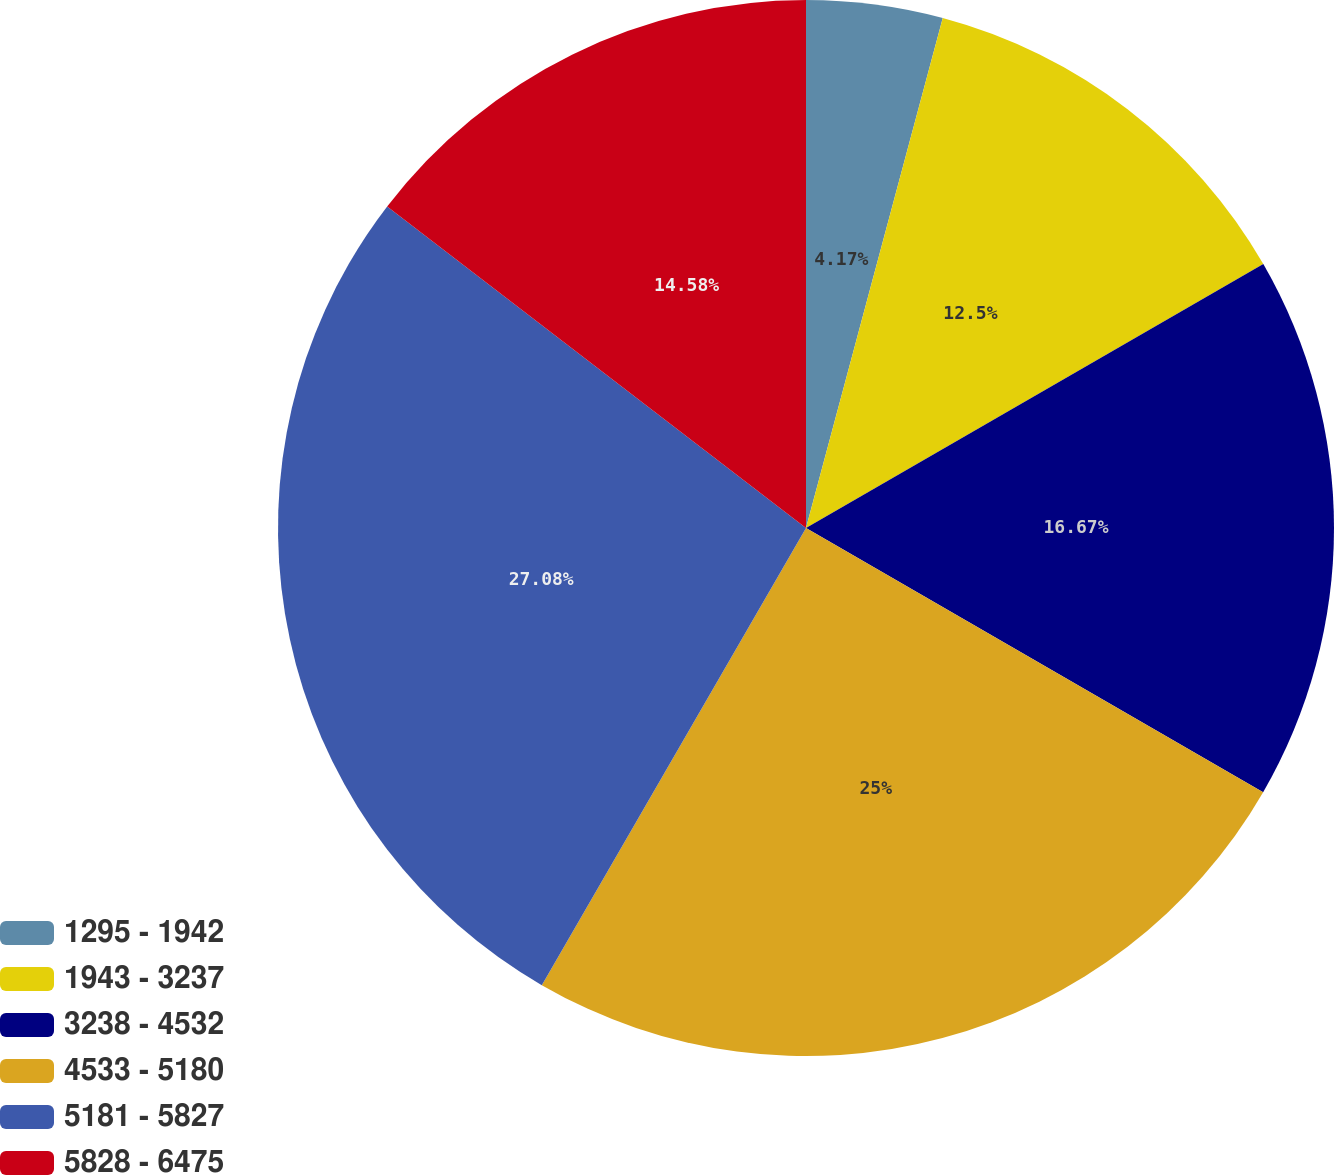<chart> <loc_0><loc_0><loc_500><loc_500><pie_chart><fcel>1295 - 1942<fcel>1943 - 3237<fcel>3238 - 4532<fcel>4533 - 5180<fcel>5181 - 5827<fcel>5828 - 6475<nl><fcel>4.17%<fcel>12.5%<fcel>16.67%<fcel>25.0%<fcel>27.08%<fcel>14.58%<nl></chart> 